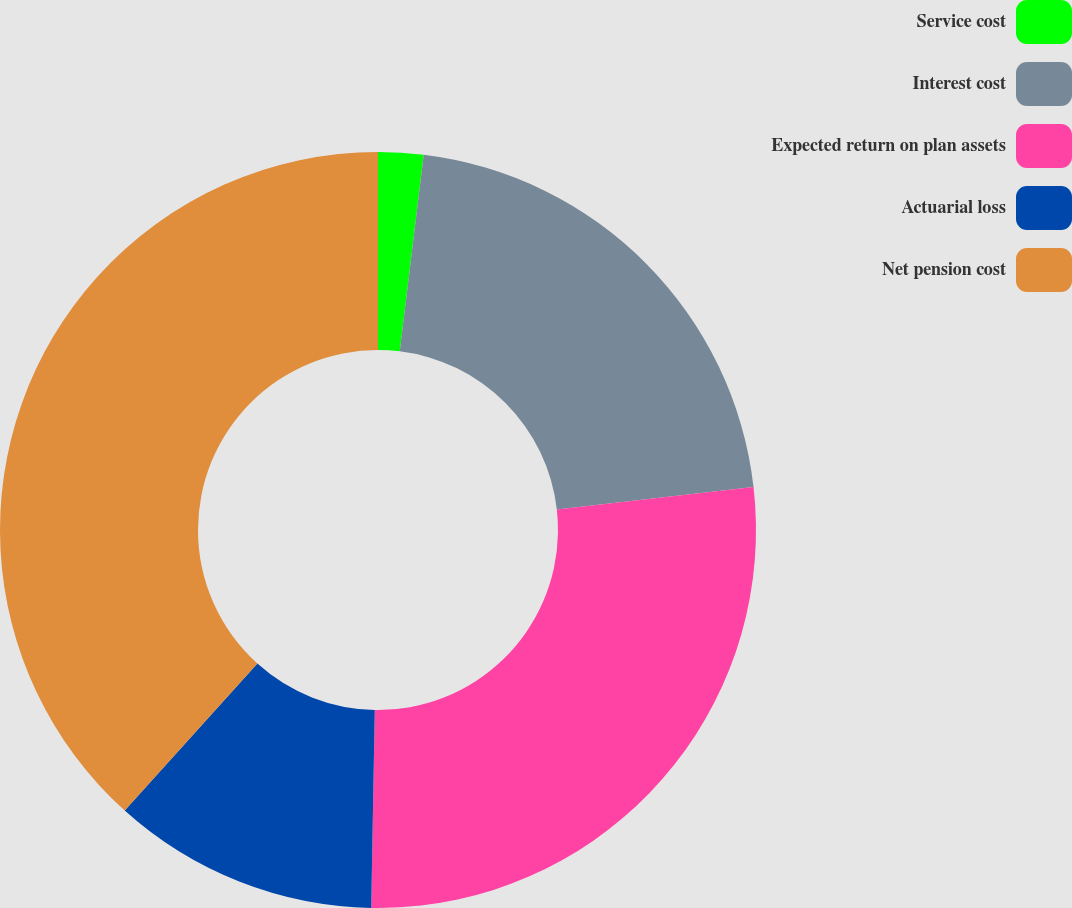Convert chart to OTSL. <chart><loc_0><loc_0><loc_500><loc_500><pie_chart><fcel>Service cost<fcel>Interest cost<fcel>Expected return on plan assets<fcel>Actuarial loss<fcel>Net pension cost<nl><fcel>1.93%<fcel>21.25%<fcel>27.1%<fcel>11.4%<fcel>38.31%<nl></chart> 